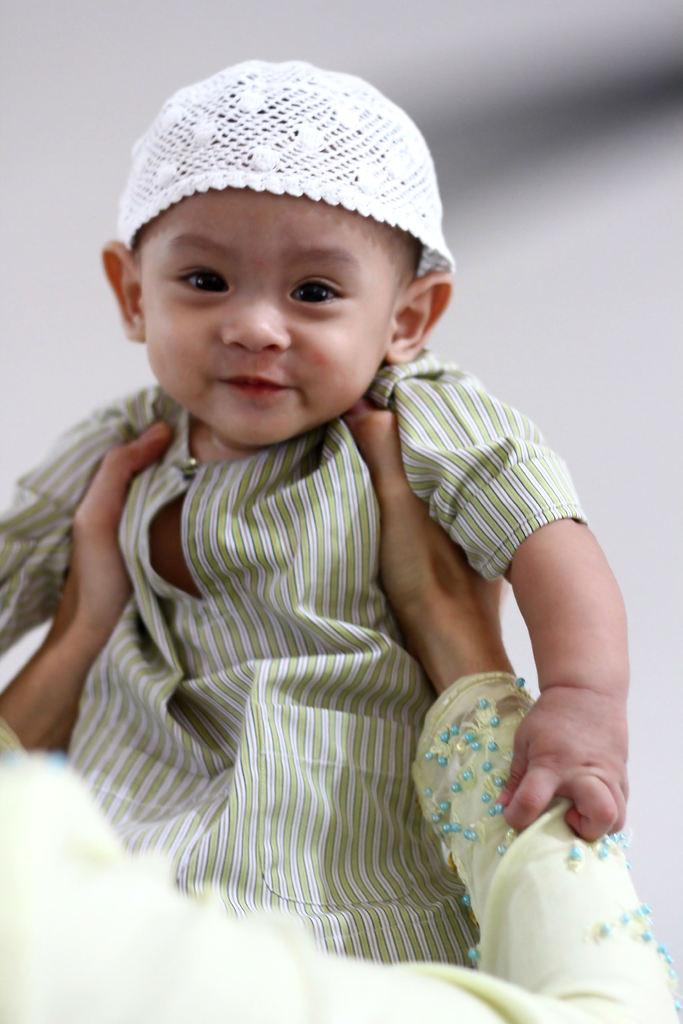What is the main subject of the image? The main subject of the image is a child. Can you describe the child's clothing? The child is wearing a green and white colored dress and a white colored hat. Who is holding the child in the image? There is a person holding the child in the image. What can be said about the background of the image? The background of the image is blurry. What type of laborer can be seen working in the background of the image? There is no laborer present in the image, and therefore no such activity can be observed. How many dogs are visible in the image? There are no dogs present in the image. 